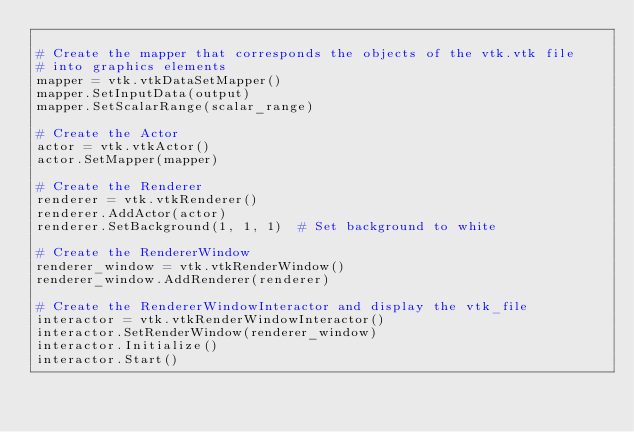<code> <loc_0><loc_0><loc_500><loc_500><_Python_>
# Create the mapper that corresponds the objects of the vtk.vtk file
# into graphics elements
mapper = vtk.vtkDataSetMapper()
mapper.SetInputData(output)
mapper.SetScalarRange(scalar_range)

# Create the Actor
actor = vtk.vtkActor()
actor.SetMapper(mapper)

# Create the Renderer
renderer = vtk.vtkRenderer()
renderer.AddActor(actor)
renderer.SetBackground(1, 1, 1)  # Set background to white

# Create the RendererWindow
renderer_window = vtk.vtkRenderWindow()
renderer_window.AddRenderer(renderer)

# Create the RendererWindowInteractor and display the vtk_file
interactor = vtk.vtkRenderWindowInteractor()
interactor.SetRenderWindow(renderer_window)
interactor.Initialize()
interactor.Start()
</code> 